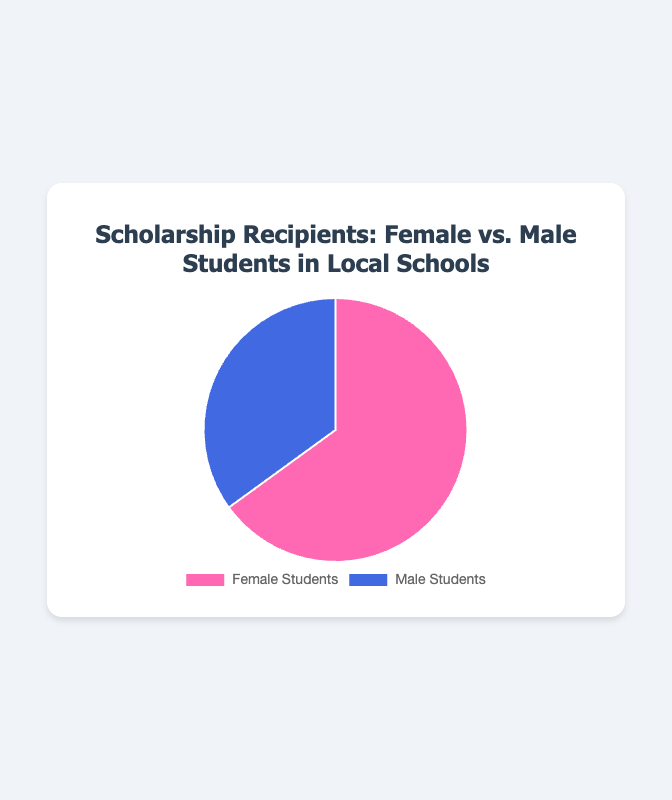What percentage of the scholarship recipients are female? The pie chart shows a segment labeled "Female Students" with a corresponding value of 65%.
Answer: 65% What is the total percentage of scholarship recipients that are male? The pie chart shows a segment labeled "Male Students" with a corresponding value of 35%.
Answer: 35% Which gender has a larger proportion of scholarship recipients? Comparing the segments, "Female Students" has a larger percentage (65%) compared to "Male Students" (35%).
Answer: Female Students What is the difference in percentage between female and male scholarship recipients? The difference is calculated as 65% (Female) - 35% (Male) = 30%.
Answer: 30% What percentage of the total scholarship recipients are either male or female? Since the scholarship recipients must be either male or female, their total must be 100%.
Answer: 100% If 100 students received scholarships, how many of them are female? Given that 65% of recipients are female, and there are 100 recipients, the calculation is 100 * 65% = 65.
Answer: 65 If there are 200 scholarship recipients, how many are male? Given that 35% of recipients are male, and there are 200 recipients, the calculation is 200 * 35% = 70.
Answer: 70 How does the color used for female students compare to that used for male students? The segment for "Female Students" is labeled with a pink color, while "Male Students" is designated with a blue color.
Answer: Pink and blue If the number of male scholarship recipients is increased by 15%, what would the new percentage of male recipients be? Adding 15% to the current 35% for male recipients results in 35% + 15% = 50%.
Answer: 50% What is the ratio of female to male scholarship recipients? The ratio is calculated as 65% (Female) to 35% (Male), which simplifies to 65/35 = 13/7.
Answer: 13:7 